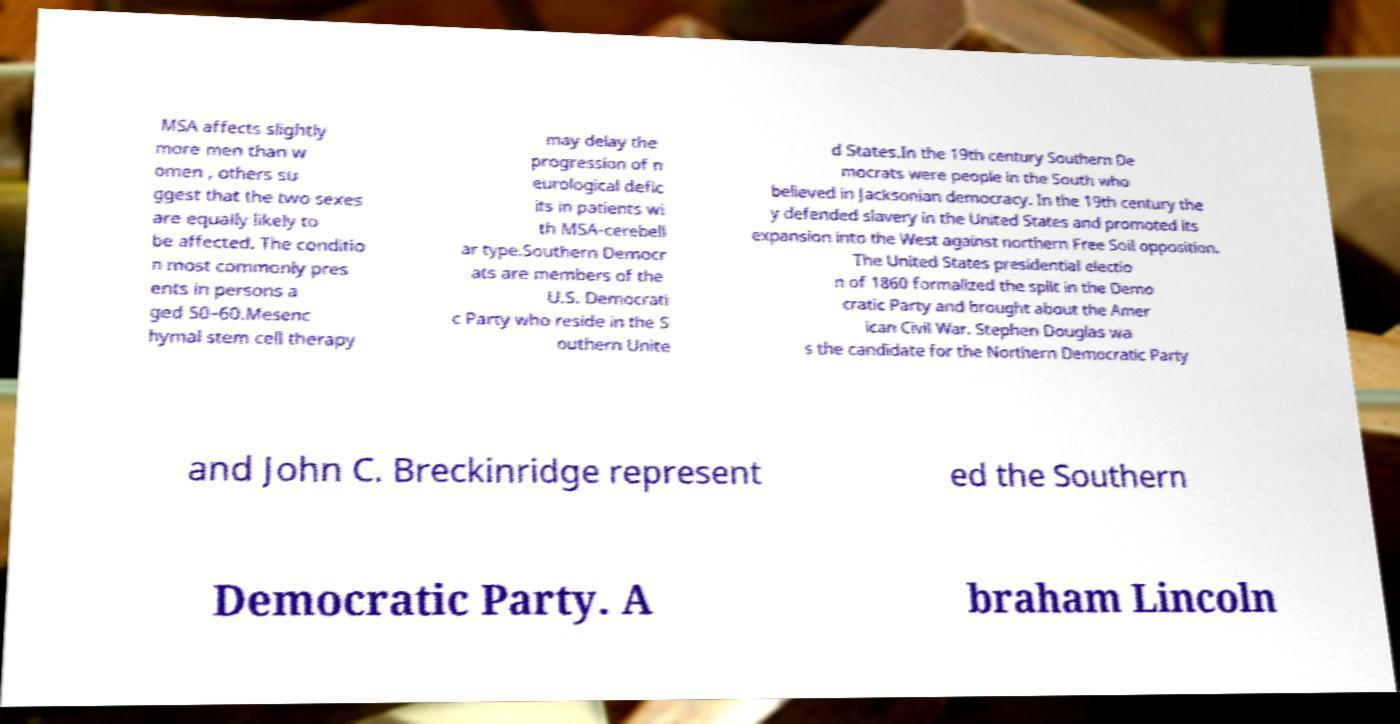Could you extract and type out the text from this image? MSA affects slightly more men than w omen , others su ggest that the two sexes are equally likely to be affected. The conditio n most commonly pres ents in persons a ged 50–60.Mesenc hymal stem cell therapy may delay the progression of n eurological defic its in patients wi th MSA-cerebell ar type.Southern Democr ats are members of the U.S. Democrati c Party who reside in the S outhern Unite d States.In the 19th century Southern De mocrats were people in the South who believed in Jacksonian democracy. In the 19th century the y defended slavery in the United States and promoted its expansion into the West against northern Free Soil opposition. The United States presidential electio n of 1860 formalized the split in the Demo cratic Party and brought about the Amer ican Civil War. Stephen Douglas wa s the candidate for the Northern Democratic Party and John C. Breckinridge represent ed the Southern Democratic Party. A braham Lincoln 